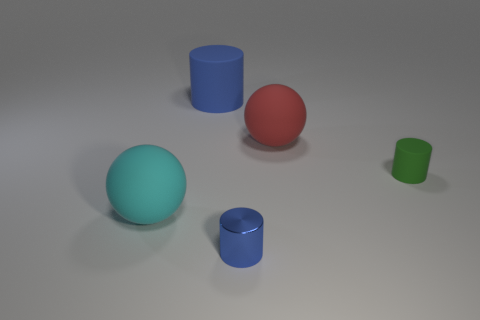Subtract all shiny cylinders. How many cylinders are left? 2 Add 2 tiny red shiny balls. How many objects exist? 7 Subtract all balls. How many objects are left? 3 Subtract all large matte spheres. Subtract all big red metal blocks. How many objects are left? 3 Add 4 large spheres. How many large spheres are left? 6 Add 1 small matte cylinders. How many small matte cylinders exist? 2 Subtract 0 yellow cubes. How many objects are left? 5 